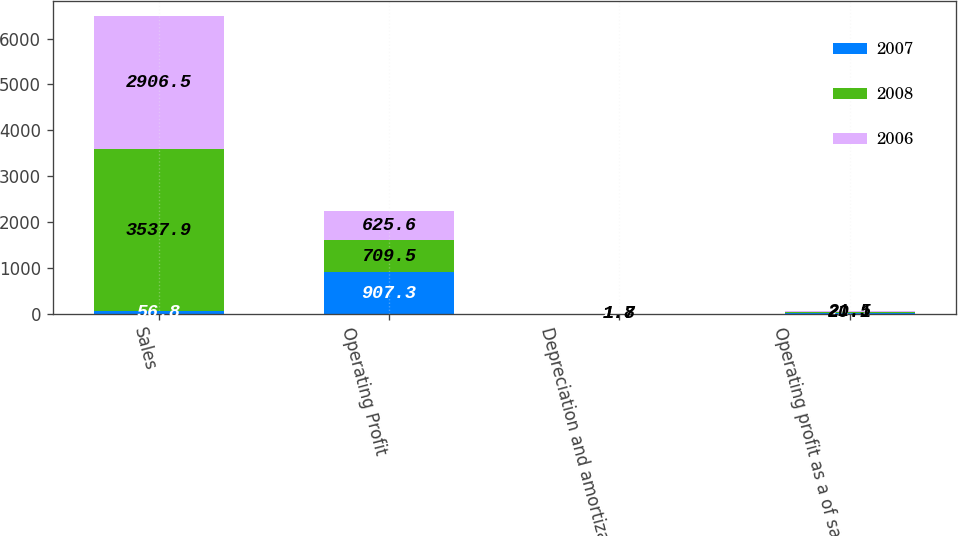Convert chart. <chart><loc_0><loc_0><loc_500><loc_500><stacked_bar_chart><ecel><fcel>Sales<fcel>Operating Profit<fcel>Depreciation and amortization<fcel>Operating profit as a of sales<nl><fcel>2007<fcel>56.8<fcel>907.3<fcel>2.7<fcel>18.7<nl><fcel>2008<fcel>3537.9<fcel>709.5<fcel>1.8<fcel>20.1<nl><fcel>2006<fcel>2906.5<fcel>625.6<fcel>1.7<fcel>21.5<nl></chart> 